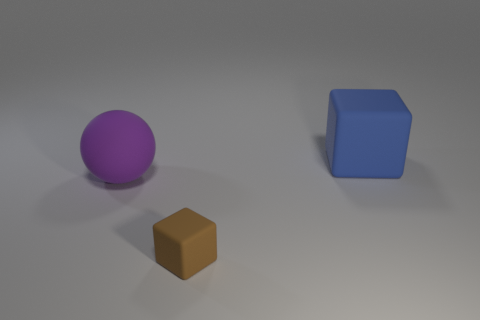Are there any other big rubber objects that have the same shape as the big purple matte thing? Based on the image provided, the purple object appears to be a sphere and there are no other objects in the image that share that same spherical shape. All objects present have distinct geometric shapes: the purple object is a sphere, the blue is a cube, and the brown object appears to be a rectangular prism. 